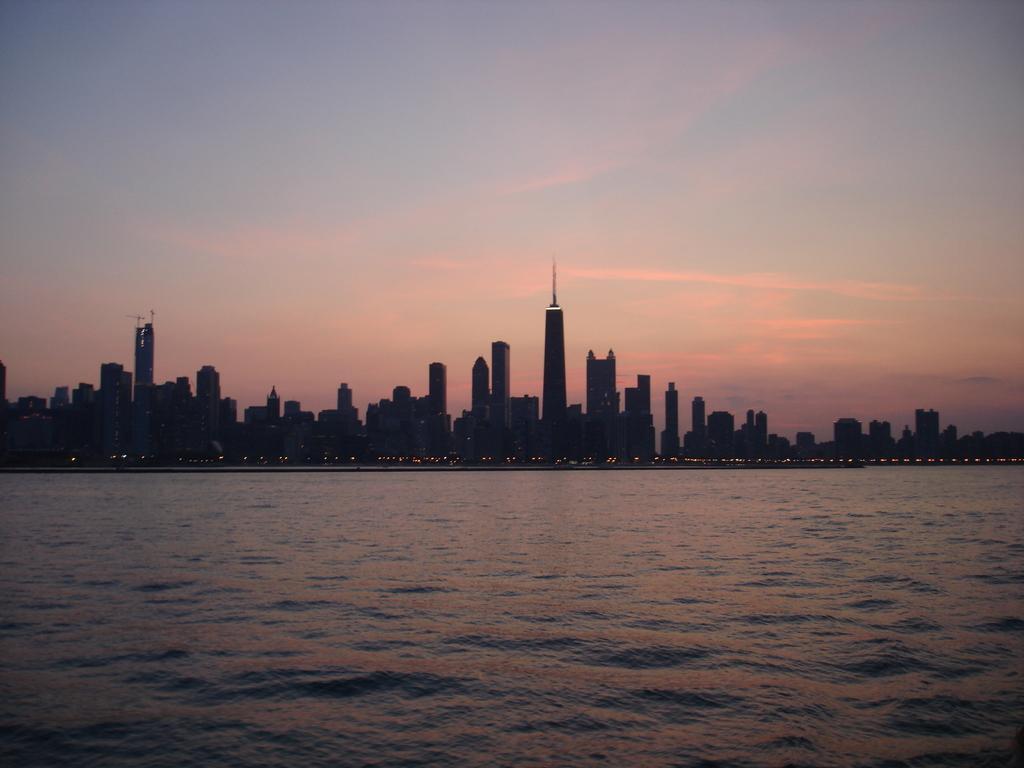Please provide a concise description of this image. In this picture we can see the skyscrapers in the image. In the front bottom side there is sea water. On the top there is a sunsets sky. 